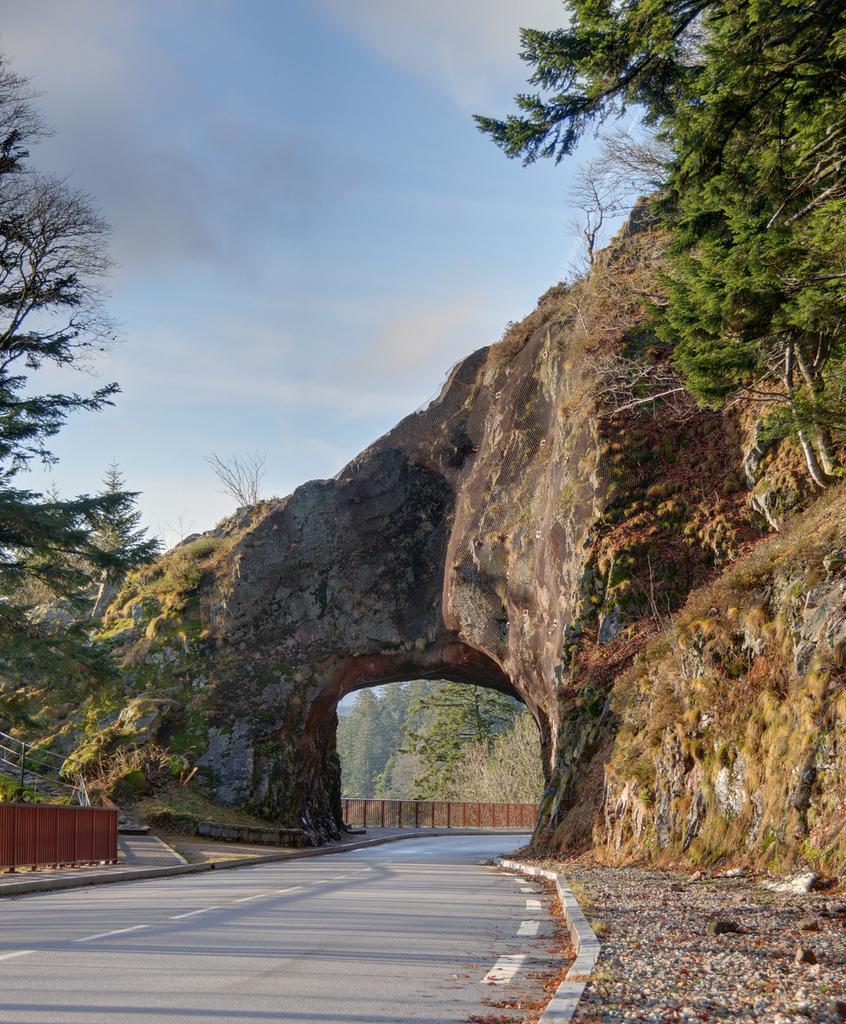Can you describe this image briefly? In the foreground of this image, there is a road and on either side there is side path and the trees. In the background, there is a cliff and an arch to it, trees, railing, sky and the cloud. 